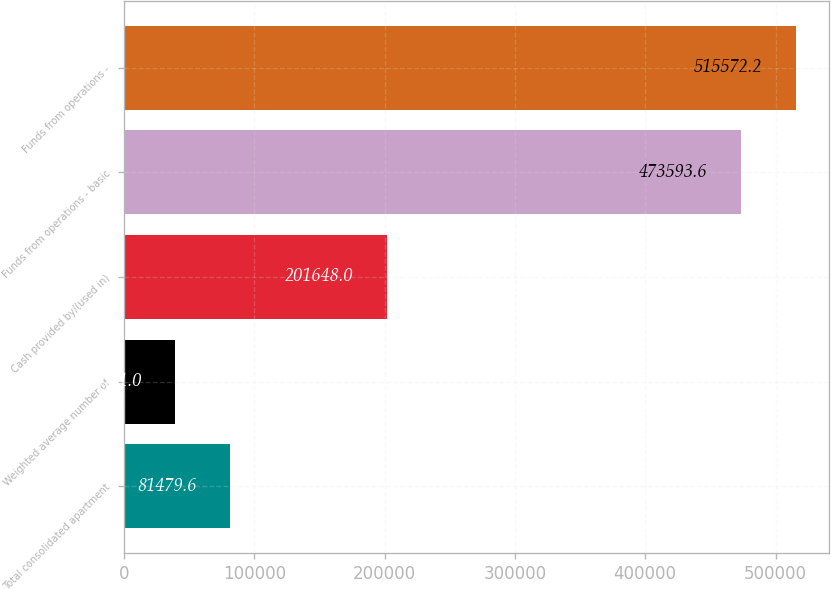Convert chart. <chart><loc_0><loc_0><loc_500><loc_500><bar_chart><fcel>Total consolidated apartment<fcel>Weighted average number of<fcel>Cash provided by/(used in)<fcel>Funds from operations - basic<fcel>Funds from operations -<nl><fcel>81479.6<fcel>39501<fcel>201648<fcel>473594<fcel>515572<nl></chart> 